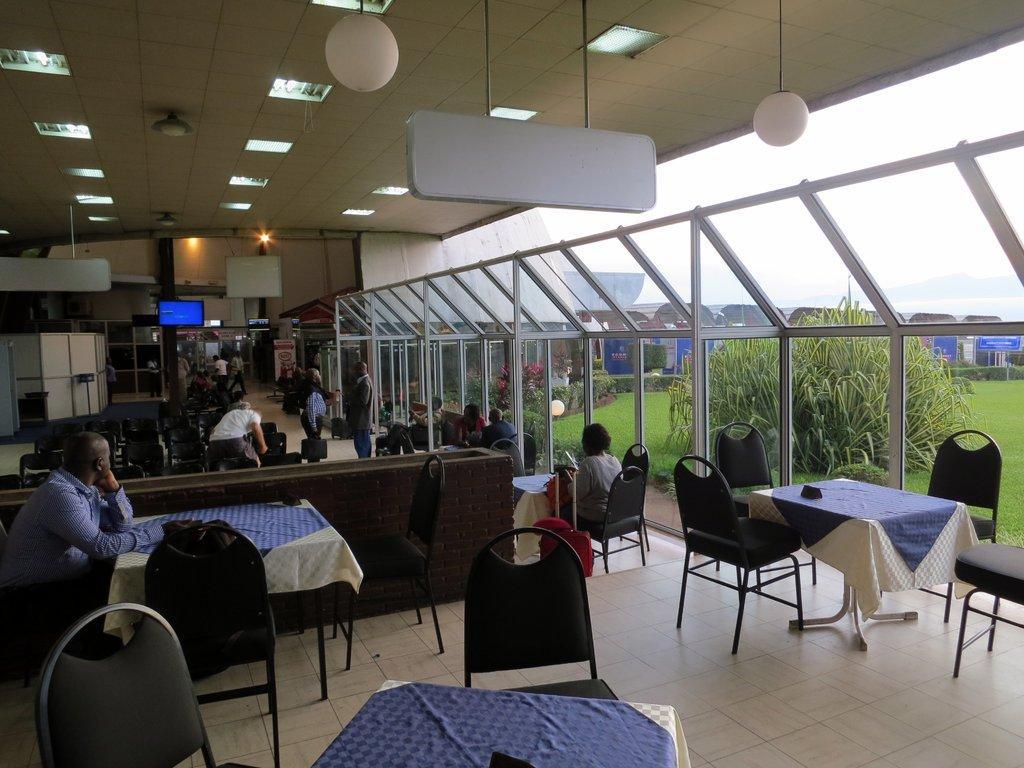Can you describe this image briefly? In this image, There are some chairs which are in black color and there are some tables which are covered by a blue color cloth, There is a black color wall in the middle, There are some people sitting on the chairs around the tables, In the right side there are some white color glass window and there are some green color plants. 